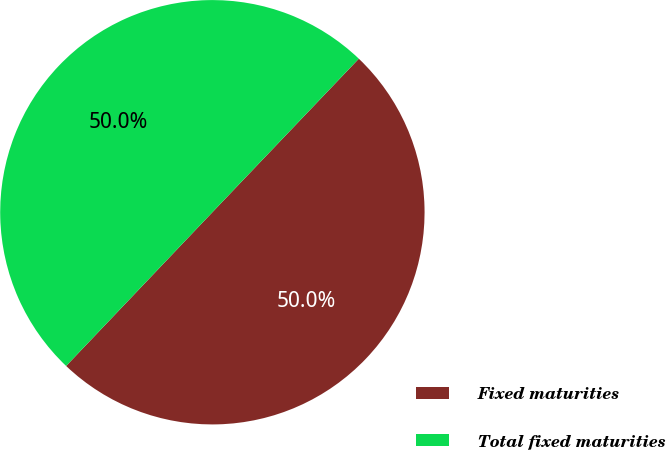<chart> <loc_0><loc_0><loc_500><loc_500><pie_chart><fcel>Fixed maturities<fcel>Total fixed maturities<nl><fcel>49.98%<fcel>50.02%<nl></chart> 